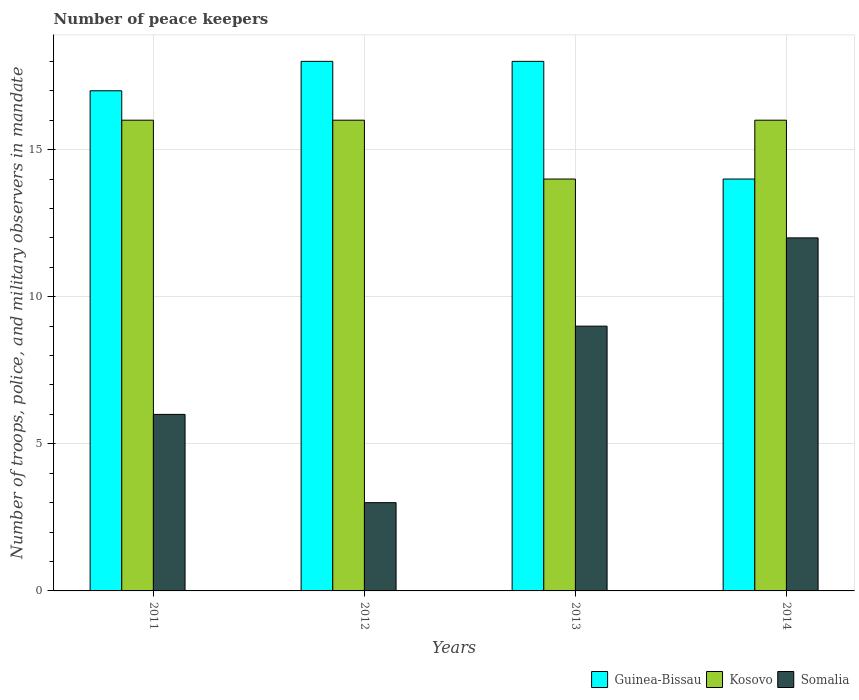How many different coloured bars are there?
Your response must be concise. 3. Are the number of bars per tick equal to the number of legend labels?
Your response must be concise. Yes. Are the number of bars on each tick of the X-axis equal?
Your answer should be very brief. Yes. In how many cases, is the number of bars for a given year not equal to the number of legend labels?
Your answer should be compact. 0. What is the number of peace keepers in in Guinea-Bissau in 2014?
Your answer should be very brief. 14. Across all years, what is the maximum number of peace keepers in in Kosovo?
Provide a short and direct response. 16. Across all years, what is the minimum number of peace keepers in in Kosovo?
Offer a terse response. 14. In which year was the number of peace keepers in in Guinea-Bissau maximum?
Your response must be concise. 2012. What is the total number of peace keepers in in Somalia in the graph?
Provide a succinct answer. 30. What is the difference between the number of peace keepers in in Somalia in 2012 and that in 2014?
Provide a short and direct response. -9. What is the difference between the number of peace keepers in in Somalia in 2014 and the number of peace keepers in in Kosovo in 2013?
Your answer should be very brief. -2. In how many years, is the number of peace keepers in in Kosovo greater than 15?
Provide a succinct answer. 3. What is the ratio of the number of peace keepers in in Kosovo in 2012 to that in 2013?
Keep it short and to the point. 1.14. Is the number of peace keepers in in Kosovo in 2012 less than that in 2013?
Keep it short and to the point. No. Is the difference between the number of peace keepers in in Guinea-Bissau in 2011 and 2013 greater than the difference between the number of peace keepers in in Kosovo in 2011 and 2013?
Your response must be concise. No. What is the difference between the highest and the second highest number of peace keepers in in Guinea-Bissau?
Provide a succinct answer. 0. What does the 2nd bar from the left in 2014 represents?
Keep it short and to the point. Kosovo. What does the 3rd bar from the right in 2013 represents?
Keep it short and to the point. Guinea-Bissau. Are all the bars in the graph horizontal?
Your answer should be compact. No. How many years are there in the graph?
Offer a terse response. 4. What is the difference between two consecutive major ticks on the Y-axis?
Offer a very short reply. 5. Does the graph contain any zero values?
Provide a succinct answer. No. Where does the legend appear in the graph?
Ensure brevity in your answer.  Bottom right. How many legend labels are there?
Your answer should be compact. 3. How are the legend labels stacked?
Provide a short and direct response. Horizontal. What is the title of the graph?
Make the answer very short. Number of peace keepers. What is the label or title of the Y-axis?
Ensure brevity in your answer.  Number of troops, police, and military observers in mandate. What is the Number of troops, police, and military observers in mandate of Guinea-Bissau in 2011?
Your answer should be compact. 17. What is the Number of troops, police, and military observers in mandate in Somalia in 2011?
Provide a short and direct response. 6. What is the Number of troops, police, and military observers in mandate in Kosovo in 2012?
Keep it short and to the point. 16. What is the Number of troops, police, and military observers in mandate in Somalia in 2013?
Your answer should be very brief. 9. What is the Number of troops, police, and military observers in mandate of Guinea-Bissau in 2014?
Make the answer very short. 14. Across all years, what is the maximum Number of troops, police, and military observers in mandate of Kosovo?
Make the answer very short. 16. Across all years, what is the maximum Number of troops, police, and military observers in mandate of Somalia?
Offer a very short reply. 12. Across all years, what is the minimum Number of troops, police, and military observers in mandate of Guinea-Bissau?
Keep it short and to the point. 14. Across all years, what is the minimum Number of troops, police, and military observers in mandate in Somalia?
Your answer should be very brief. 3. What is the total Number of troops, police, and military observers in mandate in Kosovo in the graph?
Offer a terse response. 62. What is the difference between the Number of troops, police, and military observers in mandate in Guinea-Bissau in 2011 and that in 2012?
Give a very brief answer. -1. What is the difference between the Number of troops, police, and military observers in mandate in Kosovo in 2011 and that in 2012?
Offer a very short reply. 0. What is the difference between the Number of troops, police, and military observers in mandate in Guinea-Bissau in 2011 and that in 2013?
Ensure brevity in your answer.  -1. What is the difference between the Number of troops, police, and military observers in mandate of Kosovo in 2011 and that in 2013?
Provide a succinct answer. 2. What is the difference between the Number of troops, police, and military observers in mandate in Guinea-Bissau in 2011 and that in 2014?
Make the answer very short. 3. What is the difference between the Number of troops, police, and military observers in mandate in Kosovo in 2011 and that in 2014?
Keep it short and to the point. 0. What is the difference between the Number of troops, police, and military observers in mandate in Somalia in 2011 and that in 2014?
Your response must be concise. -6. What is the difference between the Number of troops, police, and military observers in mandate of Guinea-Bissau in 2012 and that in 2014?
Offer a very short reply. 4. What is the difference between the Number of troops, police, and military observers in mandate in Somalia in 2012 and that in 2014?
Your answer should be compact. -9. What is the difference between the Number of troops, police, and military observers in mandate of Guinea-Bissau in 2013 and that in 2014?
Offer a terse response. 4. What is the difference between the Number of troops, police, and military observers in mandate in Kosovo in 2013 and that in 2014?
Give a very brief answer. -2. What is the difference between the Number of troops, police, and military observers in mandate of Guinea-Bissau in 2011 and the Number of troops, police, and military observers in mandate of Kosovo in 2013?
Keep it short and to the point. 3. What is the difference between the Number of troops, police, and military observers in mandate of Guinea-Bissau in 2011 and the Number of troops, police, and military observers in mandate of Somalia in 2013?
Offer a very short reply. 8. What is the difference between the Number of troops, police, and military observers in mandate in Kosovo in 2011 and the Number of troops, police, and military observers in mandate in Somalia in 2013?
Ensure brevity in your answer.  7. What is the difference between the Number of troops, police, and military observers in mandate in Guinea-Bissau in 2011 and the Number of troops, police, and military observers in mandate in Kosovo in 2014?
Ensure brevity in your answer.  1. What is the difference between the Number of troops, police, and military observers in mandate of Guinea-Bissau in 2011 and the Number of troops, police, and military observers in mandate of Somalia in 2014?
Offer a terse response. 5. What is the difference between the Number of troops, police, and military observers in mandate in Guinea-Bissau in 2012 and the Number of troops, police, and military observers in mandate in Somalia in 2014?
Provide a short and direct response. 6. What is the difference between the Number of troops, police, and military observers in mandate in Kosovo in 2012 and the Number of troops, police, and military observers in mandate in Somalia in 2014?
Keep it short and to the point. 4. What is the difference between the Number of troops, police, and military observers in mandate in Guinea-Bissau in 2013 and the Number of troops, police, and military observers in mandate in Kosovo in 2014?
Offer a terse response. 2. What is the difference between the Number of troops, police, and military observers in mandate in Guinea-Bissau in 2013 and the Number of troops, police, and military observers in mandate in Somalia in 2014?
Your response must be concise. 6. What is the average Number of troops, police, and military observers in mandate of Guinea-Bissau per year?
Give a very brief answer. 16.75. What is the average Number of troops, police, and military observers in mandate of Kosovo per year?
Offer a very short reply. 15.5. In the year 2011, what is the difference between the Number of troops, police, and military observers in mandate of Guinea-Bissau and Number of troops, police, and military observers in mandate of Kosovo?
Ensure brevity in your answer.  1. In the year 2011, what is the difference between the Number of troops, police, and military observers in mandate in Guinea-Bissau and Number of troops, police, and military observers in mandate in Somalia?
Offer a very short reply. 11. In the year 2011, what is the difference between the Number of troops, police, and military observers in mandate of Kosovo and Number of troops, police, and military observers in mandate of Somalia?
Your response must be concise. 10. In the year 2012, what is the difference between the Number of troops, police, and military observers in mandate in Guinea-Bissau and Number of troops, police, and military observers in mandate in Kosovo?
Provide a short and direct response. 2. In the year 2012, what is the difference between the Number of troops, police, and military observers in mandate in Guinea-Bissau and Number of troops, police, and military observers in mandate in Somalia?
Give a very brief answer. 15. In the year 2012, what is the difference between the Number of troops, police, and military observers in mandate in Kosovo and Number of troops, police, and military observers in mandate in Somalia?
Your response must be concise. 13. In the year 2013, what is the difference between the Number of troops, police, and military observers in mandate in Guinea-Bissau and Number of troops, police, and military observers in mandate in Kosovo?
Provide a short and direct response. 4. In the year 2013, what is the difference between the Number of troops, police, and military observers in mandate of Guinea-Bissau and Number of troops, police, and military observers in mandate of Somalia?
Your answer should be very brief. 9. In the year 2013, what is the difference between the Number of troops, police, and military observers in mandate of Kosovo and Number of troops, police, and military observers in mandate of Somalia?
Your answer should be very brief. 5. In the year 2014, what is the difference between the Number of troops, police, and military observers in mandate in Kosovo and Number of troops, police, and military observers in mandate in Somalia?
Provide a succinct answer. 4. What is the ratio of the Number of troops, police, and military observers in mandate of Guinea-Bissau in 2011 to that in 2012?
Provide a short and direct response. 0.94. What is the ratio of the Number of troops, police, and military observers in mandate in Guinea-Bissau in 2011 to that in 2013?
Make the answer very short. 0.94. What is the ratio of the Number of troops, police, and military observers in mandate in Kosovo in 2011 to that in 2013?
Offer a very short reply. 1.14. What is the ratio of the Number of troops, police, and military observers in mandate of Guinea-Bissau in 2011 to that in 2014?
Provide a short and direct response. 1.21. What is the ratio of the Number of troops, police, and military observers in mandate of Kosovo in 2011 to that in 2014?
Offer a terse response. 1. What is the ratio of the Number of troops, police, and military observers in mandate in Guinea-Bissau in 2012 to that in 2013?
Offer a very short reply. 1. What is the ratio of the Number of troops, police, and military observers in mandate in Kosovo in 2012 to that in 2013?
Provide a short and direct response. 1.14. What is the ratio of the Number of troops, police, and military observers in mandate of Kosovo in 2013 to that in 2014?
Your answer should be compact. 0.88. What is the difference between the highest and the second highest Number of troops, police, and military observers in mandate in Guinea-Bissau?
Your answer should be compact. 0. What is the difference between the highest and the lowest Number of troops, police, and military observers in mandate in Kosovo?
Offer a terse response. 2. What is the difference between the highest and the lowest Number of troops, police, and military observers in mandate of Somalia?
Provide a succinct answer. 9. 